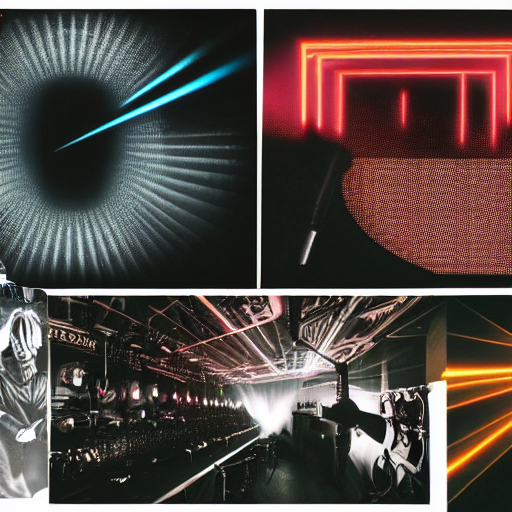Is the quality of the image good?
A. Average
B. No
C. Yes
Answer with the option's letter from the given choices directly.
 C. 